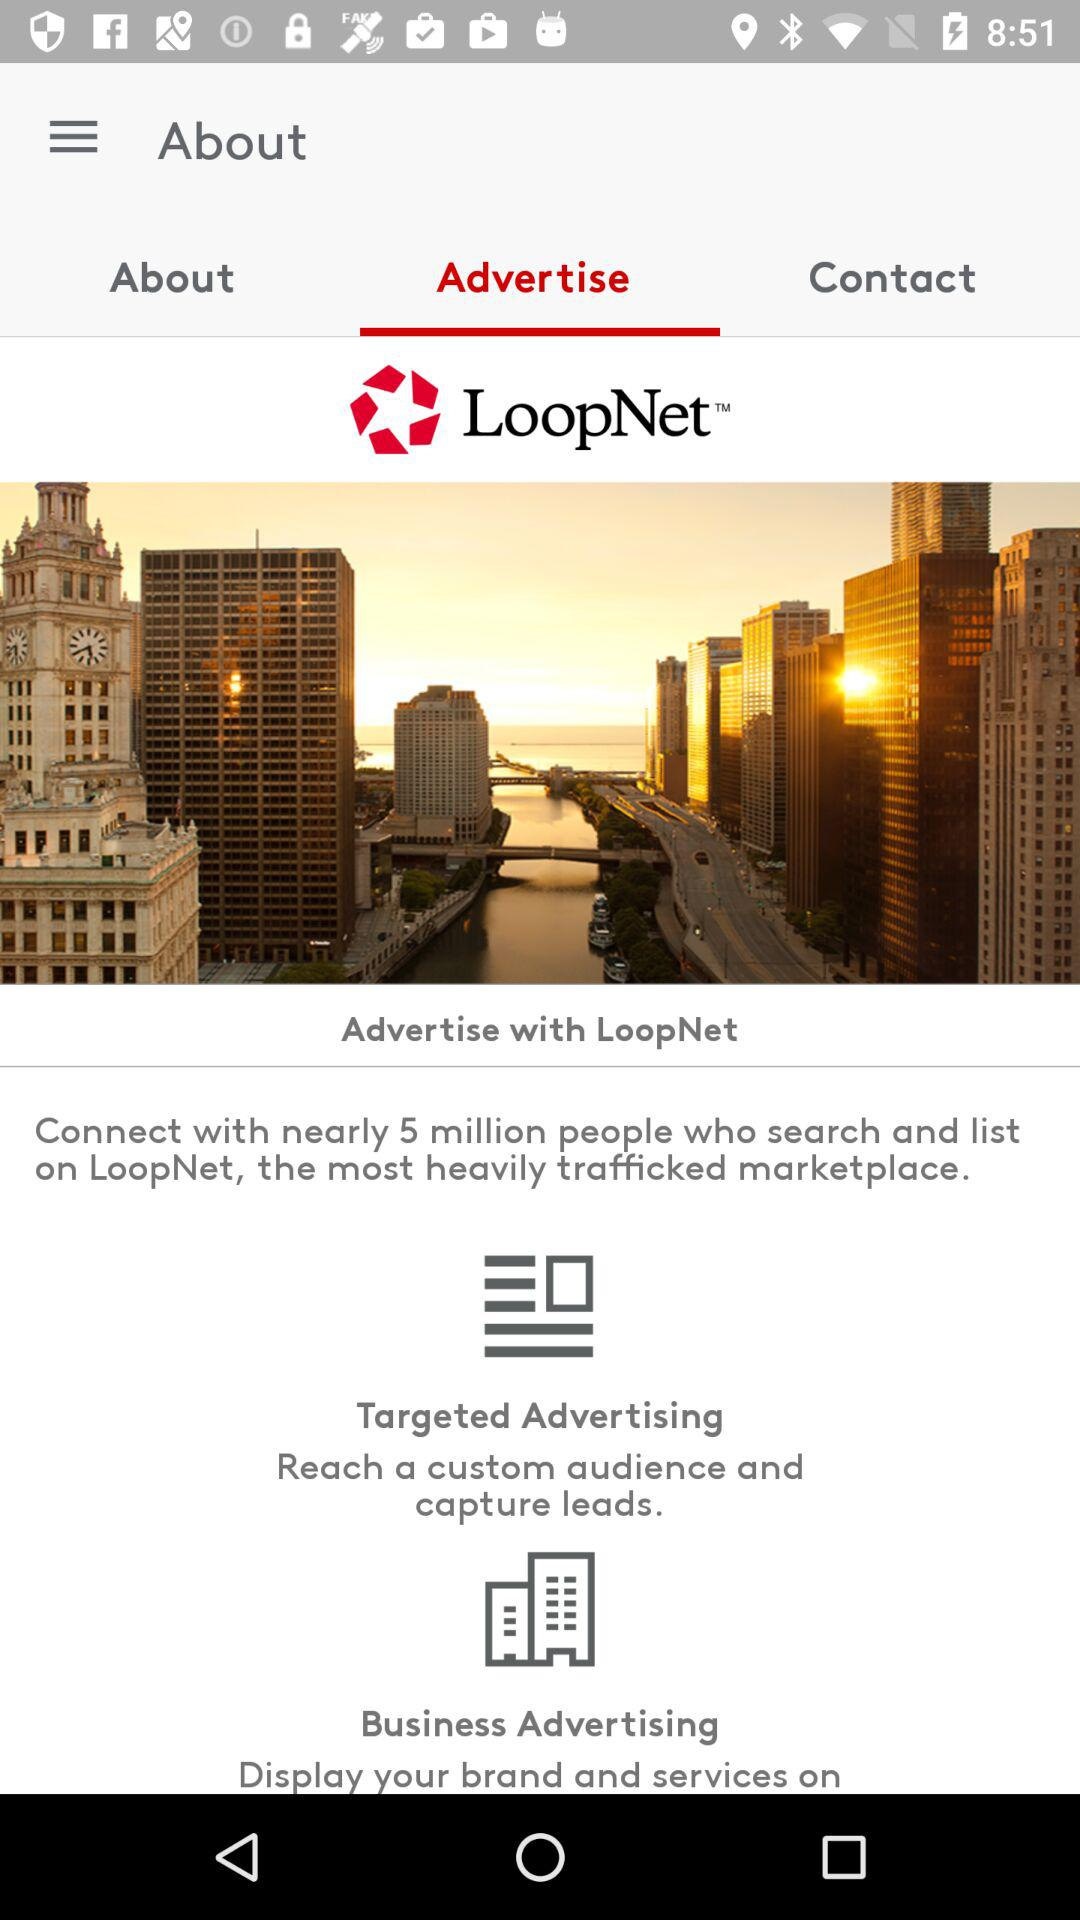How many people can the user connect with? The user can connect with nearly 5 million people. 